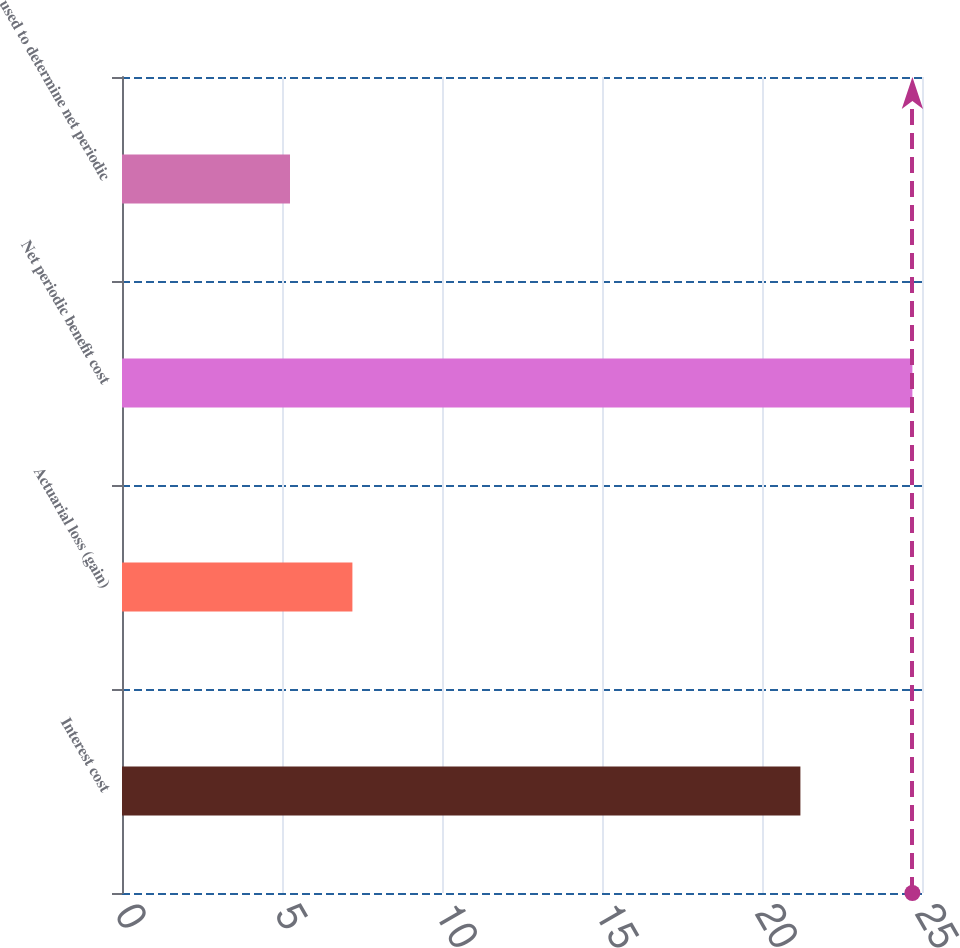<chart> <loc_0><loc_0><loc_500><loc_500><bar_chart><fcel>Interest cost<fcel>Actuarial loss (gain)<fcel>Net periodic benefit cost<fcel>used to determine net periodic<nl><fcel>21.2<fcel>7.2<fcel>24.7<fcel>5.25<nl></chart> 